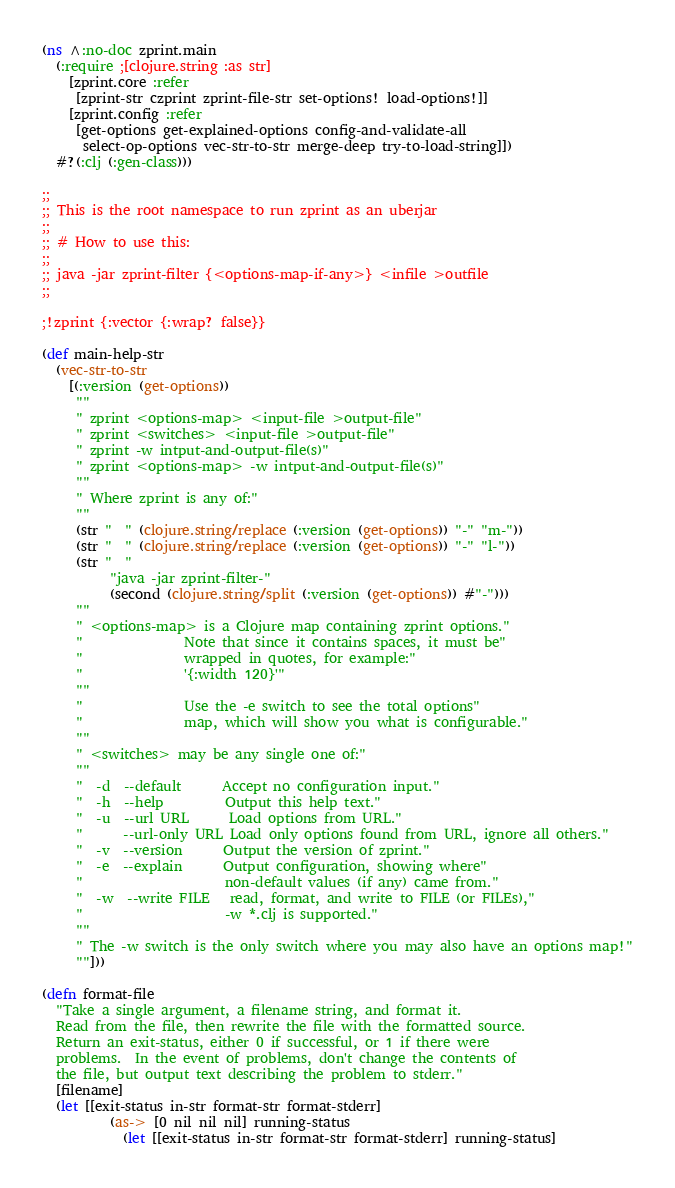Convert code to text. <code><loc_0><loc_0><loc_500><loc_500><_Clojure_>(ns ^:no-doc zprint.main
  (:require ;[clojure.string :as str]
    [zprint.core :refer
     [zprint-str czprint zprint-file-str set-options! load-options!]]
    [zprint.config :refer
     [get-options get-explained-options config-and-validate-all
      select-op-options vec-str-to-str merge-deep try-to-load-string]])
  #?(:clj (:gen-class)))

;;
;; This is the root namespace to run zprint as an uberjar
;;
;; # How to use this:
;;
;; java -jar zprint-filter {<options-map-if-any>} <infile >outfile
;;

;!zprint {:vector {:wrap? false}}

(def main-help-str
  (vec-str-to-str
    [(:version (get-options))
     ""
     " zprint <options-map> <input-file >output-file"
     " zprint <switches> <input-file >output-file"
     " zprint -w intput-and-output-file(s)"
     " zprint <options-map> -w intput-and-output-file(s)"
     ""
     " Where zprint is any of:"
     ""
     (str "  " (clojure.string/replace (:version (get-options)) "-" "m-"))
     (str "  " (clojure.string/replace (:version (get-options)) "-" "l-"))
     (str "  "
          "java -jar zprint-filter-"
          (second (clojure.string/split (:version (get-options)) #"-")))
     ""
     " <options-map> is a Clojure map containing zprint options."
     "               Note that since it contains spaces, it must be"
     "               wrapped in quotes, for example:"
     "               '{:width 120}'"
     ""
     "               Use the -e switch to see the total options"
     "               map, which will show you what is configurable."
     ""
     " <switches> may be any single one of:"
     ""
     "  -d  --default      Accept no configuration input."
     "  -h  --help         Output this help text."
     "  -u  --url URL      Load options from URL."
     "      --url-only URL Load only options found from URL, ignore all others."
     "  -v  --version      Output the version of zprint."
     "  -e  --explain      Output configuration, showing where"
     "                     non-default values (if any) came from."
     "  -w  --write FILE   read, format, and write to FILE (or FILEs),"
     "                     -w *.clj is supported."
     ""
     " The -w switch is the only switch where you may also have an options map!"
     ""]))

(defn format-file
  "Take a single argument, a filename string, and format it.
  Read from the file, then rewrite the file with the formatted source.
  Return an exit-status, either 0 if successful, or 1 if there were
  problems.  In the event of problems, don't change the contents of
  the file, but output text describing the problem to stderr."
  [filename]
  (let [[exit-status in-str format-str format-stderr]
          (as-> [0 nil nil nil] running-status
            (let [[exit-status in-str format-str format-stderr] running-status]</code> 